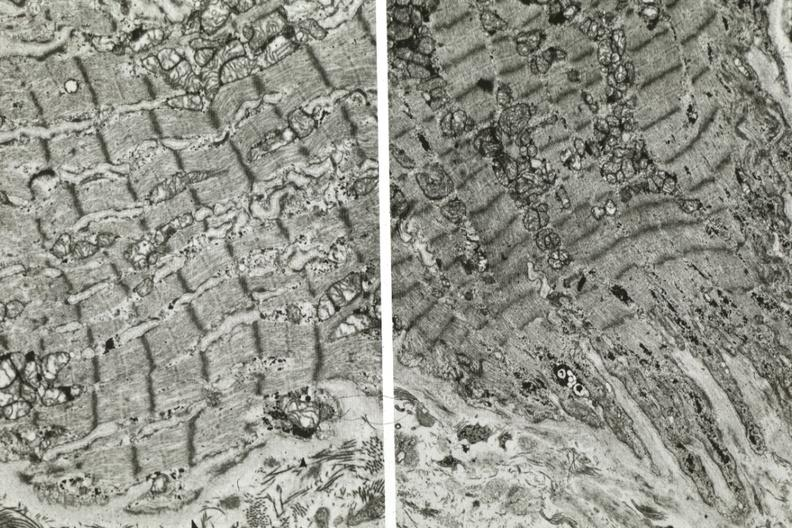s atrophy present?
Answer the question using a single word or phrase. Yes 